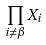Convert formula to latex. <formula><loc_0><loc_0><loc_500><loc_500>\prod _ { i \ne \beta } X _ { i }</formula> 